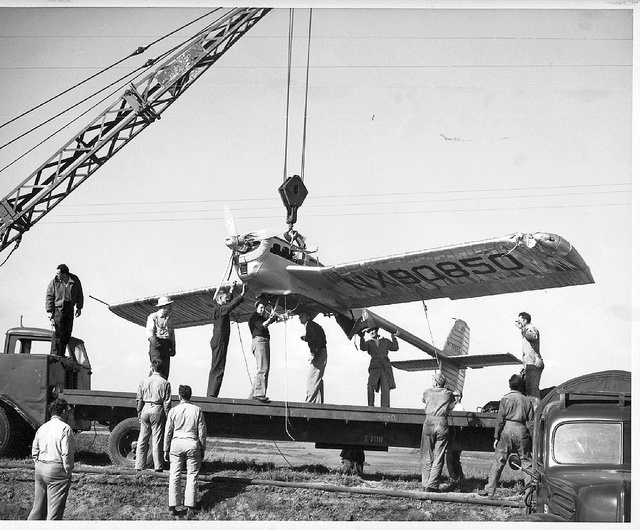Describe the objects in this image and their specific colors. I can see truck in lightgray, black, gray, and darkgray tones, airplane in lightgray, gray, black, white, and darkgray tones, truck in lightgray, gray, darkgray, and black tones, people in lightgray, white, black, gray, and darkgray tones, and people in lightgray, gray, black, and darkgray tones in this image. 